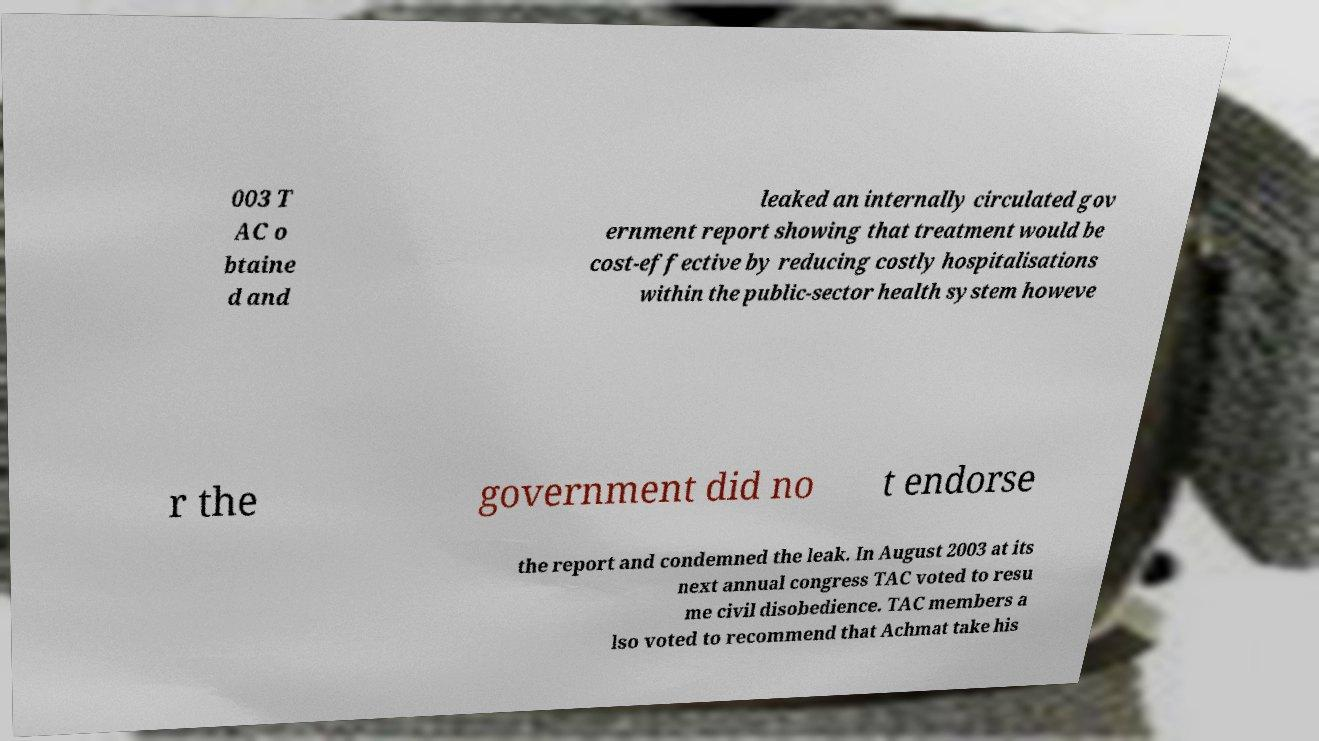Please read and relay the text visible in this image. What does it say? 003 T AC o btaine d and leaked an internally circulated gov ernment report showing that treatment would be cost-effective by reducing costly hospitalisations within the public-sector health system howeve r the government did no t endorse the report and condemned the leak. In August 2003 at its next annual congress TAC voted to resu me civil disobedience. TAC members a lso voted to recommend that Achmat take his 